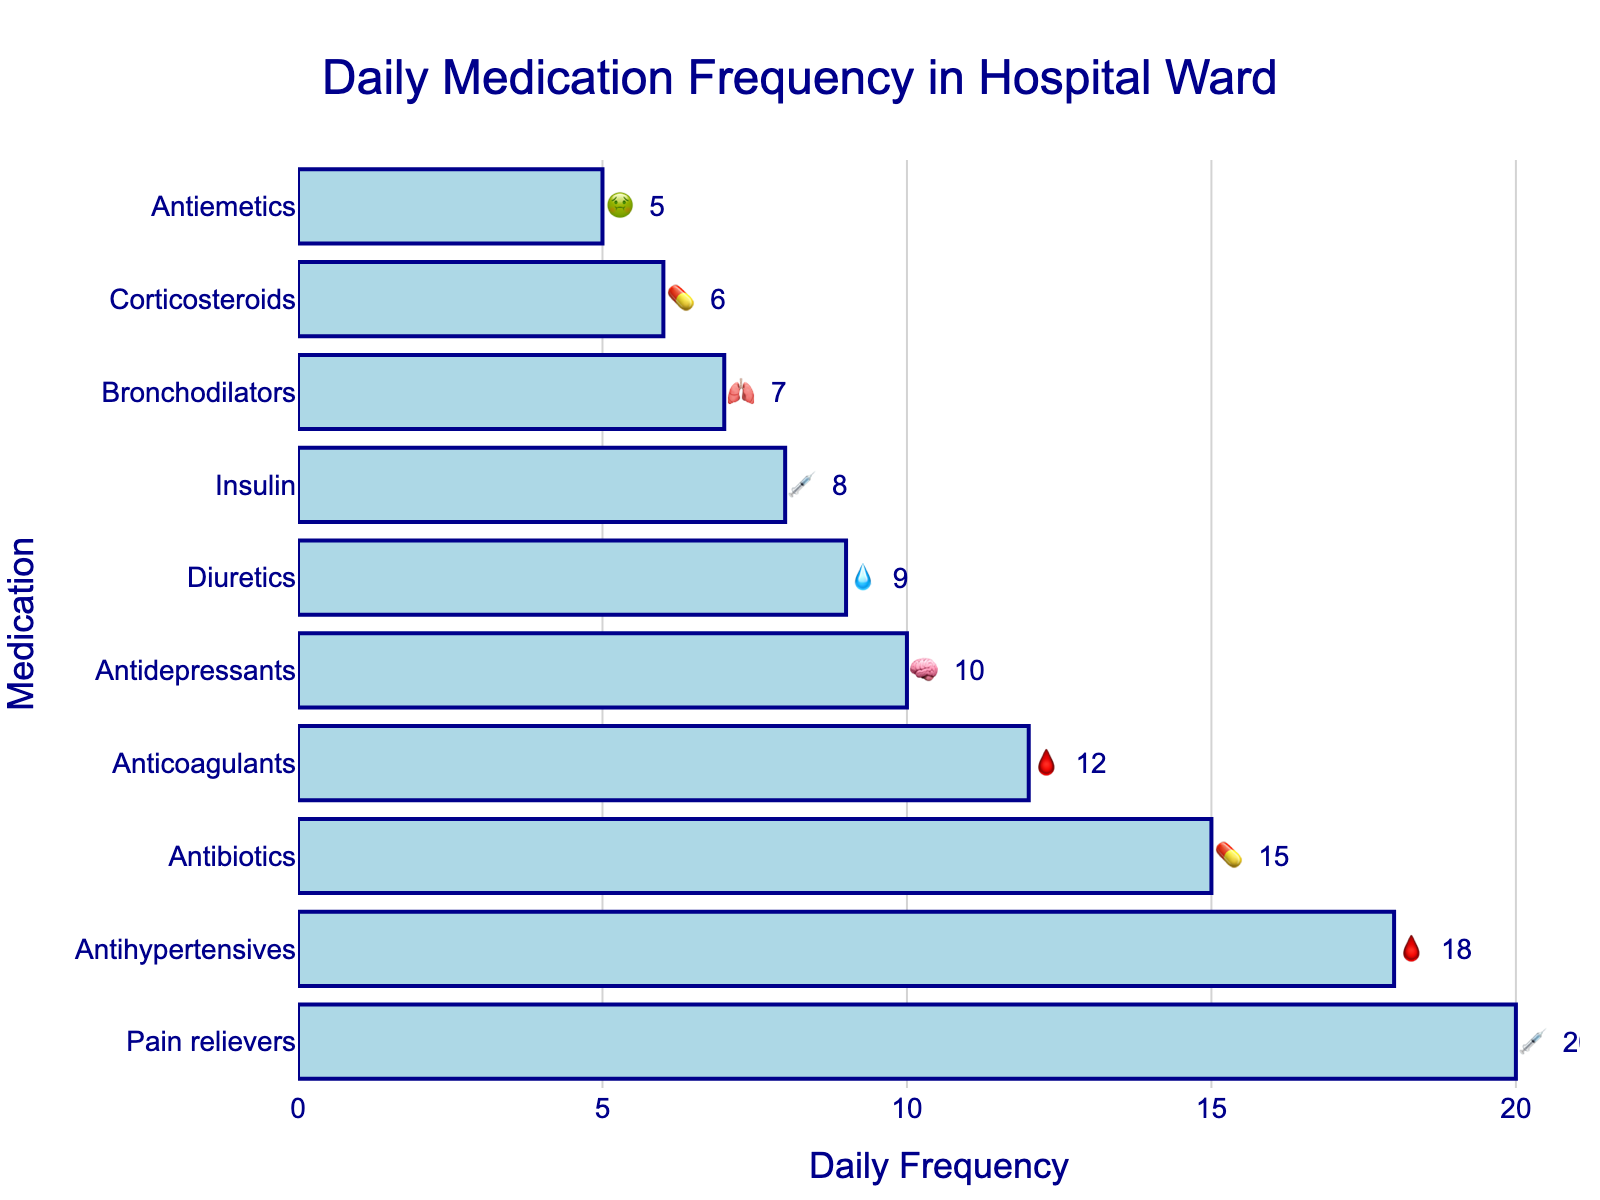what is the title of the figure? The title is usually displayed at the top of the figure. Here, the title shown at the top center is "Daily Medication Frequency in Hospital Ward."
Answer: Daily Medication Frequency in Hospital Ward Which medication is administered the most frequently daily? To find out which medication has the highest daily frequency, look at the bar with the highest value on the x-axis. In this case, the "Pain relievers" (💉) bar is the longest, indicating it is administered the most frequently.
Answer: Pain relievers (💉) What's the combined daily frequency of Antihypertensives and Anticoagulants? To calculate the combined frequency, add the daily frequencies of both medications. Antihypertensives (🩸) have a daily frequency of 18, and Anticoagulants (🩸) have 12. So, 18 + 12 = 30.
Answer: 30 How many types of medications are shown in the figure? You can count the different bars in the figure. Each bar represents a unique type of medication. Counting the bars yields 10 different medications.
Answer: 10 Which medications share the same emoji (🩸), and what are their combined daily frequencies? Look for the emoji 🩸 in the figure. "Antihypertensives" and "Anticoagulants" share this emoji. Their daily frequencies are 18 and 12, respectively. Summing these, 18 + 12 = 30.
Answer: Antihypertensives and Anticoagulants, 30 Which medication has the second highest daily frequency? To find this, identify the second longest bar. The bar for Antihypertensives (🩸) is the second longest with a daily frequency of 18.
Answer: Antihypertensives (🩸) What's the total daily frequency for all medications combined? Add up all the daily frequencies provided: 15 (💊) + 20 (💉) + 18 (🩸) + 12 (🩸) + 8 (💉) + 6 (💊) + 10 (🧠) + 7 (🫁) + 9 (💧) + 5 (🤢). The total is 110.
Answer: 110 Is the frequency for Corticosteroids higher or lower than for Diuretics? Compare the bars for Corticosteroids (💊) and Diuretics (💧). Corticosteroids have a frequency of 6, while Diuretics have 9. Therefore, Corticosteroids have a lower frequency than Diuretics.
Answer: Lower 